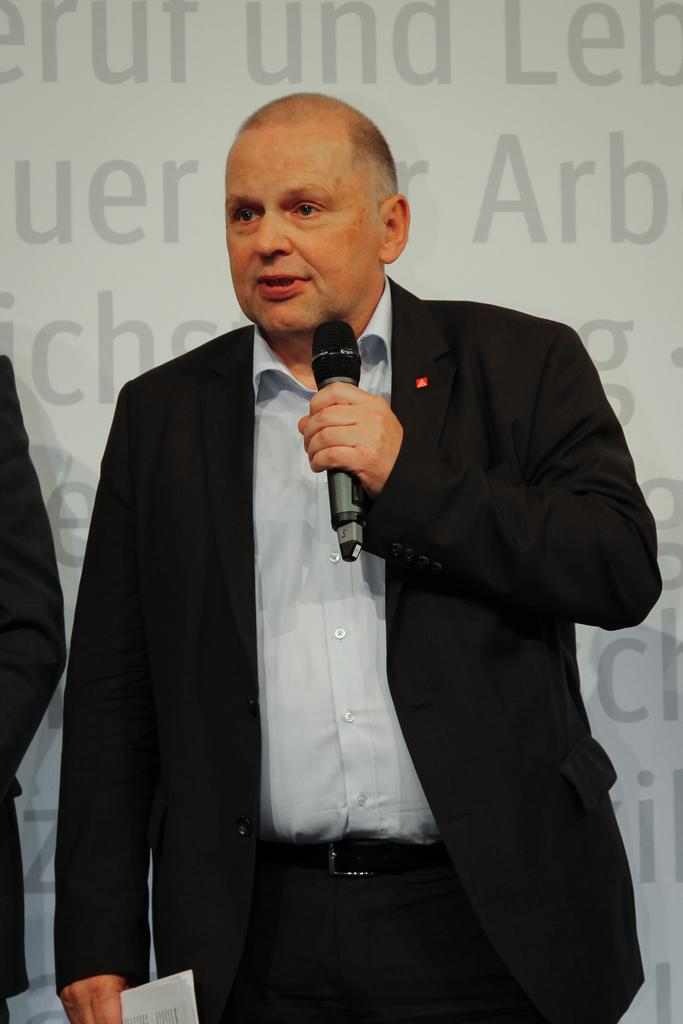Who is present in the image? There is a man in the image. What is the man doing in the image? The man is standing and holding a mic in his hand. What can be seen in the background of the image? There is a wall in the background of the image. What type of feast is the man preparing in the image? There is no feast present in the image; the man is holding a mic. What type of sticks can be seen in the man's hand in the image? There are no sticks visible in the man's hand in the image; he is holding a mic. 